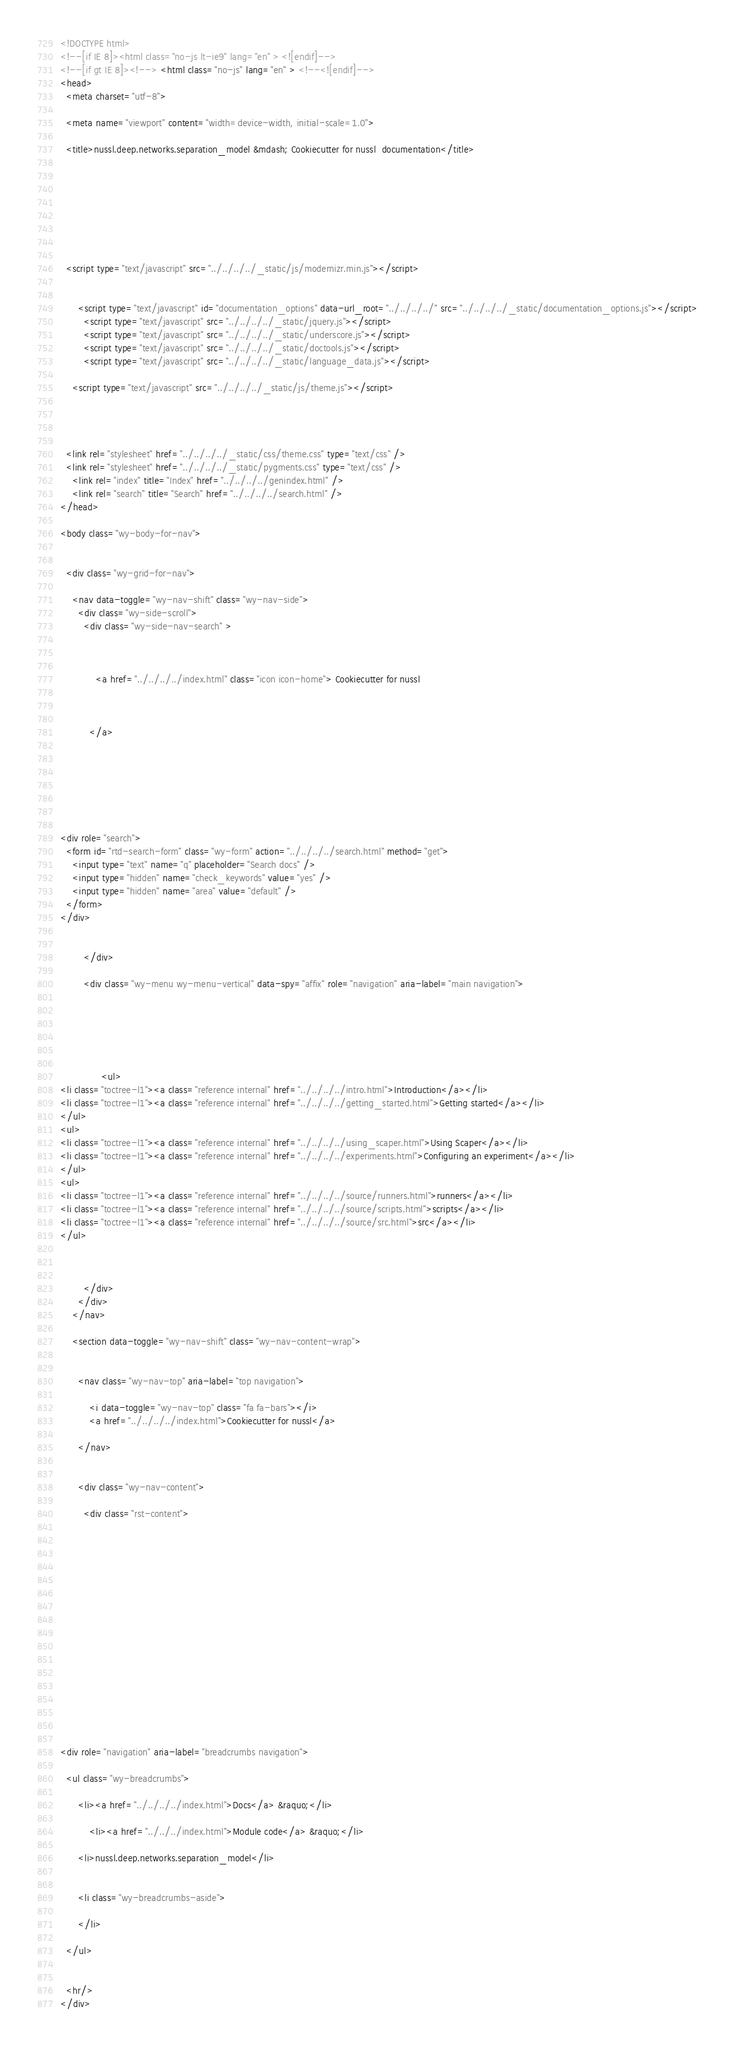Convert code to text. <code><loc_0><loc_0><loc_500><loc_500><_HTML_>

<!DOCTYPE html>
<!--[if IE 8]><html class="no-js lt-ie9" lang="en" > <![endif]-->
<!--[if gt IE 8]><!--> <html class="no-js" lang="en" > <!--<![endif]-->
<head>
  <meta charset="utf-8">
  
  <meta name="viewport" content="width=device-width, initial-scale=1.0">
  
  <title>nussl.deep.networks.separation_model &mdash; Cookiecutter for nussl  documentation</title>
  

  
  
  
  

  
  <script type="text/javascript" src="../../../../_static/js/modernizr.min.js"></script>
  
    
      <script type="text/javascript" id="documentation_options" data-url_root="../../../../" src="../../../../_static/documentation_options.js"></script>
        <script type="text/javascript" src="../../../../_static/jquery.js"></script>
        <script type="text/javascript" src="../../../../_static/underscore.js"></script>
        <script type="text/javascript" src="../../../../_static/doctools.js"></script>
        <script type="text/javascript" src="../../../../_static/language_data.js"></script>
    
    <script type="text/javascript" src="../../../../_static/js/theme.js"></script>

    

  
  <link rel="stylesheet" href="../../../../_static/css/theme.css" type="text/css" />
  <link rel="stylesheet" href="../../../../_static/pygments.css" type="text/css" />
    <link rel="index" title="Index" href="../../../../genindex.html" />
    <link rel="search" title="Search" href="../../../../search.html" /> 
</head>

<body class="wy-body-for-nav">

   
  <div class="wy-grid-for-nav">
    
    <nav data-toggle="wy-nav-shift" class="wy-nav-side">
      <div class="wy-side-scroll">
        <div class="wy-side-nav-search" >
          

          
            <a href="../../../../index.html" class="icon icon-home"> Cookiecutter for nussl
          

          
          </a>

          
            
            
          

          
<div role="search">
  <form id="rtd-search-form" class="wy-form" action="../../../../search.html" method="get">
    <input type="text" name="q" placeholder="Search docs" />
    <input type="hidden" name="check_keywords" value="yes" />
    <input type="hidden" name="area" value="default" />
  </form>
</div>

          
        </div>

        <div class="wy-menu wy-menu-vertical" data-spy="affix" role="navigation" aria-label="main navigation">
          
            
            
              
            
            
              <ul>
<li class="toctree-l1"><a class="reference internal" href="../../../../intro.html">Introduction</a></li>
<li class="toctree-l1"><a class="reference internal" href="../../../../getting_started.html">Getting started</a></li>
</ul>
<ul>
<li class="toctree-l1"><a class="reference internal" href="../../../../using_scaper.html">Using Scaper</a></li>
<li class="toctree-l1"><a class="reference internal" href="../../../../experiments.html">Configuring an experiment</a></li>
</ul>
<ul>
<li class="toctree-l1"><a class="reference internal" href="../../../../source/runners.html">runners</a></li>
<li class="toctree-l1"><a class="reference internal" href="../../../../source/scripts.html">scripts</a></li>
<li class="toctree-l1"><a class="reference internal" href="../../../../source/src.html">src</a></li>
</ul>

            
          
        </div>
      </div>
    </nav>

    <section data-toggle="wy-nav-shift" class="wy-nav-content-wrap">

      
      <nav class="wy-nav-top" aria-label="top navigation">
        
          <i data-toggle="wy-nav-top" class="fa fa-bars"></i>
          <a href="../../../../index.html">Cookiecutter for nussl</a>
        
      </nav>


      <div class="wy-nav-content">
        
        <div class="rst-content">
        
          















<div role="navigation" aria-label="breadcrumbs navigation">

  <ul class="wy-breadcrumbs">
    
      <li><a href="../../../../index.html">Docs</a> &raquo;</li>
        
          <li><a href="../../../index.html">Module code</a> &raquo;</li>
        
      <li>nussl.deep.networks.separation_model</li>
    
    
      <li class="wy-breadcrumbs-aside">
        
      </li>
    
  </ul>

  
  <hr/>
</div></code> 